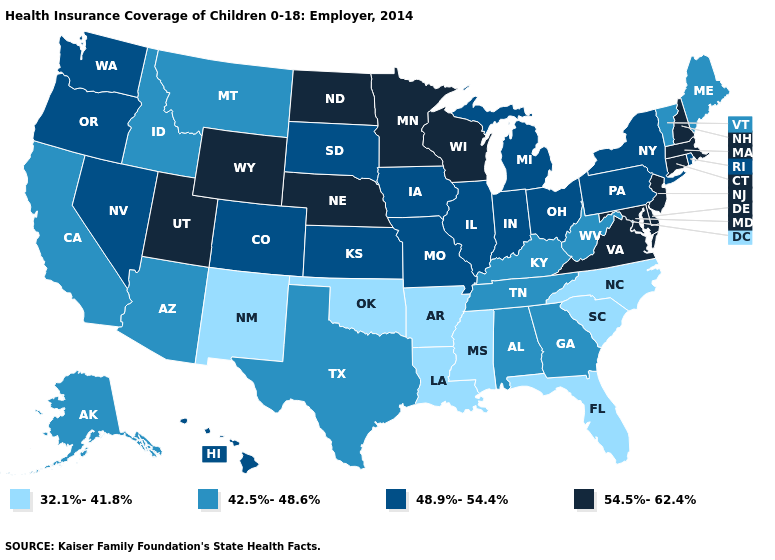What is the highest value in states that border Massachusetts?
Quick response, please. 54.5%-62.4%. What is the highest value in the Northeast ?
Short answer required. 54.5%-62.4%. Among the states that border New Hampshire , does Massachusetts have the lowest value?
Answer briefly. No. Which states have the lowest value in the Northeast?
Be succinct. Maine, Vermont. What is the value of Delaware?
Give a very brief answer. 54.5%-62.4%. What is the value of Nebraska?
Concise answer only. 54.5%-62.4%. Name the states that have a value in the range 42.5%-48.6%?
Short answer required. Alabama, Alaska, Arizona, California, Georgia, Idaho, Kentucky, Maine, Montana, Tennessee, Texas, Vermont, West Virginia. What is the value of Rhode Island?
Concise answer only. 48.9%-54.4%. What is the value of New York?
Write a very short answer. 48.9%-54.4%. Does Texas have the same value as California?
Be succinct. Yes. What is the value of Oklahoma?
Concise answer only. 32.1%-41.8%. Which states have the highest value in the USA?
Answer briefly. Connecticut, Delaware, Maryland, Massachusetts, Minnesota, Nebraska, New Hampshire, New Jersey, North Dakota, Utah, Virginia, Wisconsin, Wyoming. Does the first symbol in the legend represent the smallest category?
Quick response, please. Yes. Name the states that have a value in the range 54.5%-62.4%?
Keep it brief. Connecticut, Delaware, Maryland, Massachusetts, Minnesota, Nebraska, New Hampshire, New Jersey, North Dakota, Utah, Virginia, Wisconsin, Wyoming. Does Minnesota have the lowest value in the MidWest?
Be succinct. No. 